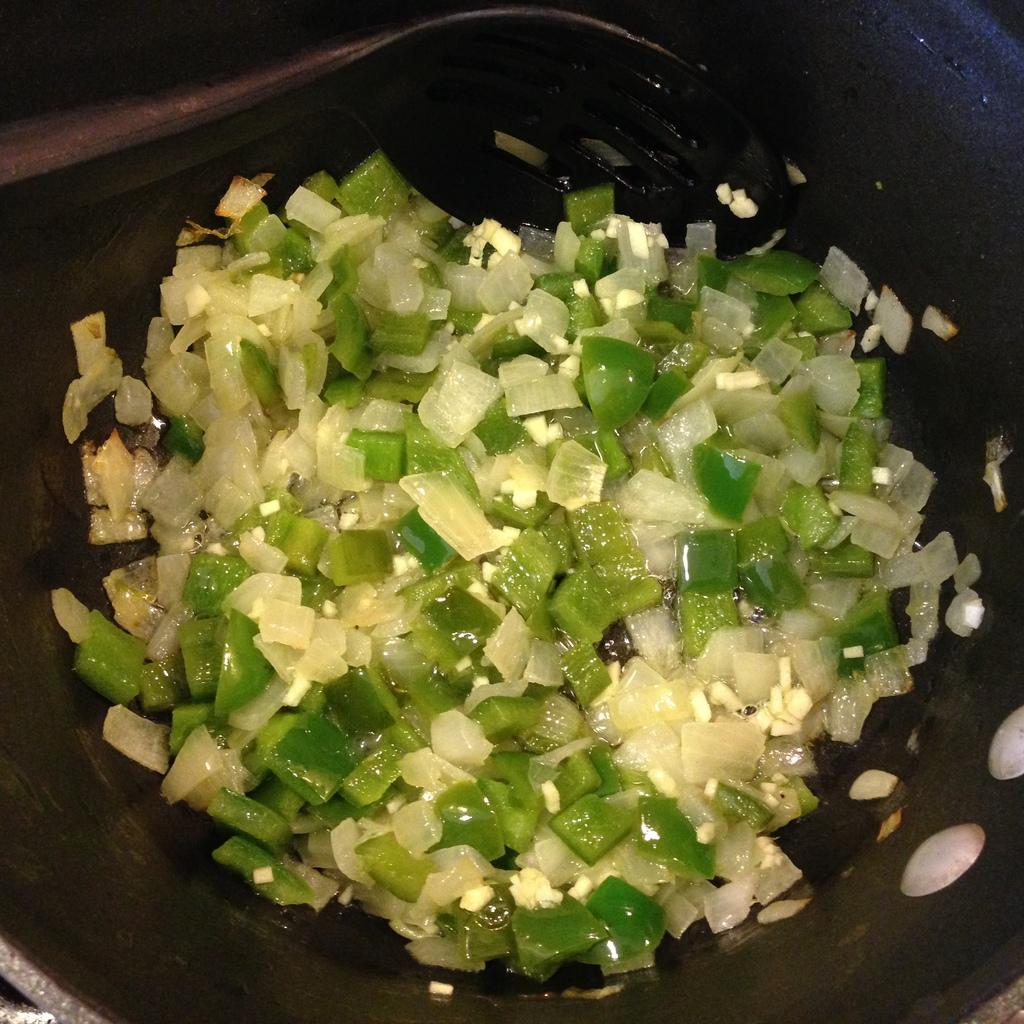What type of vegetables are chopped and visible in the image? There are chopped onions and capsicum in the image. Where are the chopped vegetables located? The onions and capsicum are in a pan. What decision did the chopped onions make in the image? There is no decision-making process involved with chopped onions, as they are inanimate objects. 